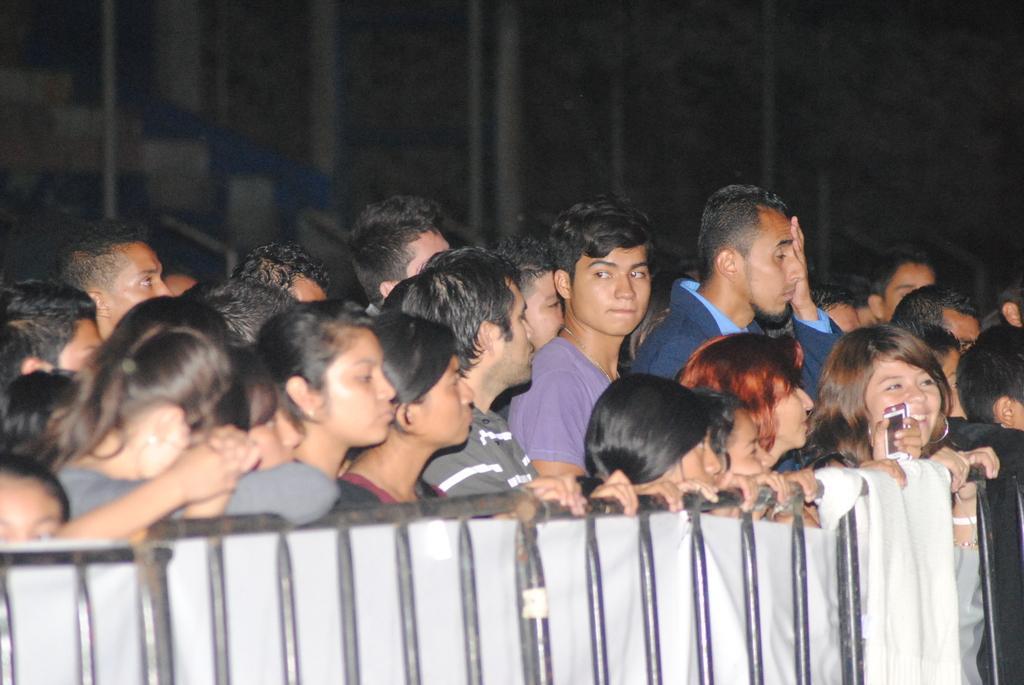How would you summarize this image in a sentence or two? There is a crowd. In front of them there is a railing with cloth. 